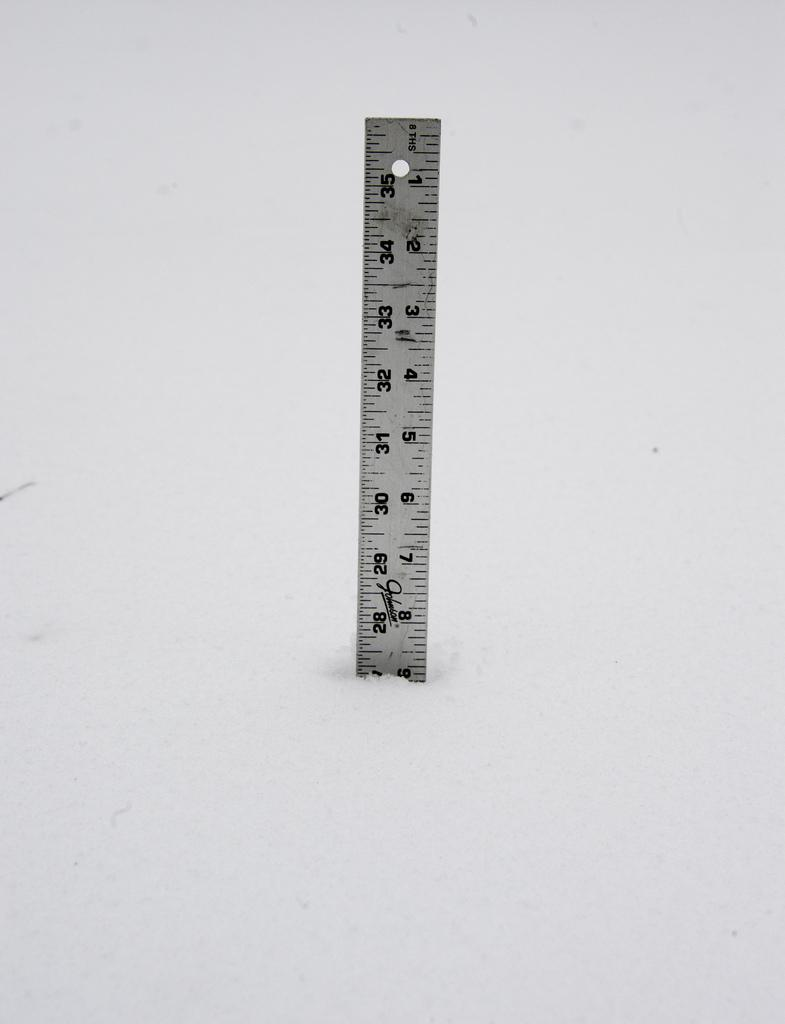<image>
Summarize the visual content of the image. Ruler that has the letters THS on it. 